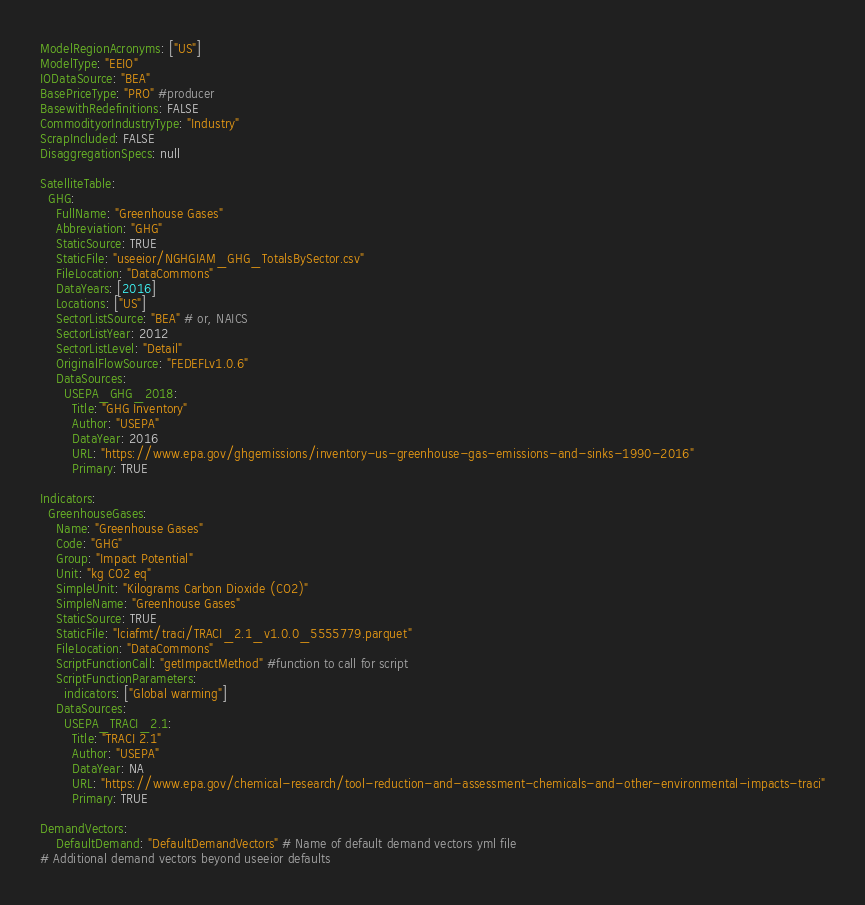Convert code to text. <code><loc_0><loc_0><loc_500><loc_500><_YAML_>ModelRegionAcronyms: ["US"]
ModelType: "EEIO"
IODataSource: "BEA"
BasePriceType: "PRO" #producer
BasewithRedefinitions: FALSE
CommodityorIndustryType: "Industry"
ScrapIncluded: FALSE
DisaggregationSpecs: null

SatelliteTable:
  GHG:
    FullName: "Greenhouse Gases"
    Abbreviation: "GHG"
    StaticSource: TRUE
    StaticFile: "useeior/NGHGIAM_GHG_TotalsBySector.csv"
    FileLocation: "DataCommons"
    DataYears: [2016]
    Locations: ["US"]
    SectorListSource: "BEA" # or, NAICS
    SectorListYear: 2012
    SectorListLevel: "Detail"
    OriginalFlowSource: "FEDEFLv1.0.6"
    DataSources:
      USEPA_GHG_2018:
        Title: "GHG Inventory"
        Author: "USEPA"
        DataYear: 2016
        URL: "https://www.epa.gov/ghgemissions/inventory-us-greenhouse-gas-emissions-and-sinks-1990-2016"
        Primary: TRUE

Indicators:
  GreenhouseGases:
    Name: "Greenhouse Gases"
    Code: "GHG"
    Group: "Impact Potential"
    Unit: "kg CO2 eq"
    SimpleUnit: "Kilograms Carbon Dioxide (CO2)"
    SimpleName: "Greenhouse Gases"
    StaticSource: TRUE
    StaticFile: "lciafmt/traci/TRACI_2.1_v1.0.0_5555779.parquet"
    FileLocation: "DataCommons"
    ScriptFunctionCall: "getImpactMethod" #function to call for script
    ScriptFunctionParameters: 
      indicators: ["Global warming"]
    DataSources:
      USEPA_TRACI_2.1:
        Title: "TRACI 2.1"
        Author: "USEPA"
        DataYear: NA
        URL: "https://www.epa.gov/chemical-research/tool-reduction-and-assessment-chemicals-and-other-environmental-impacts-traci"
        Primary: TRUE

DemandVectors:
    DefaultDemand: "DefaultDemandVectors" # Name of default demand vectors yml file
# Additional demand vectors beyond useeior defaults
</code> 